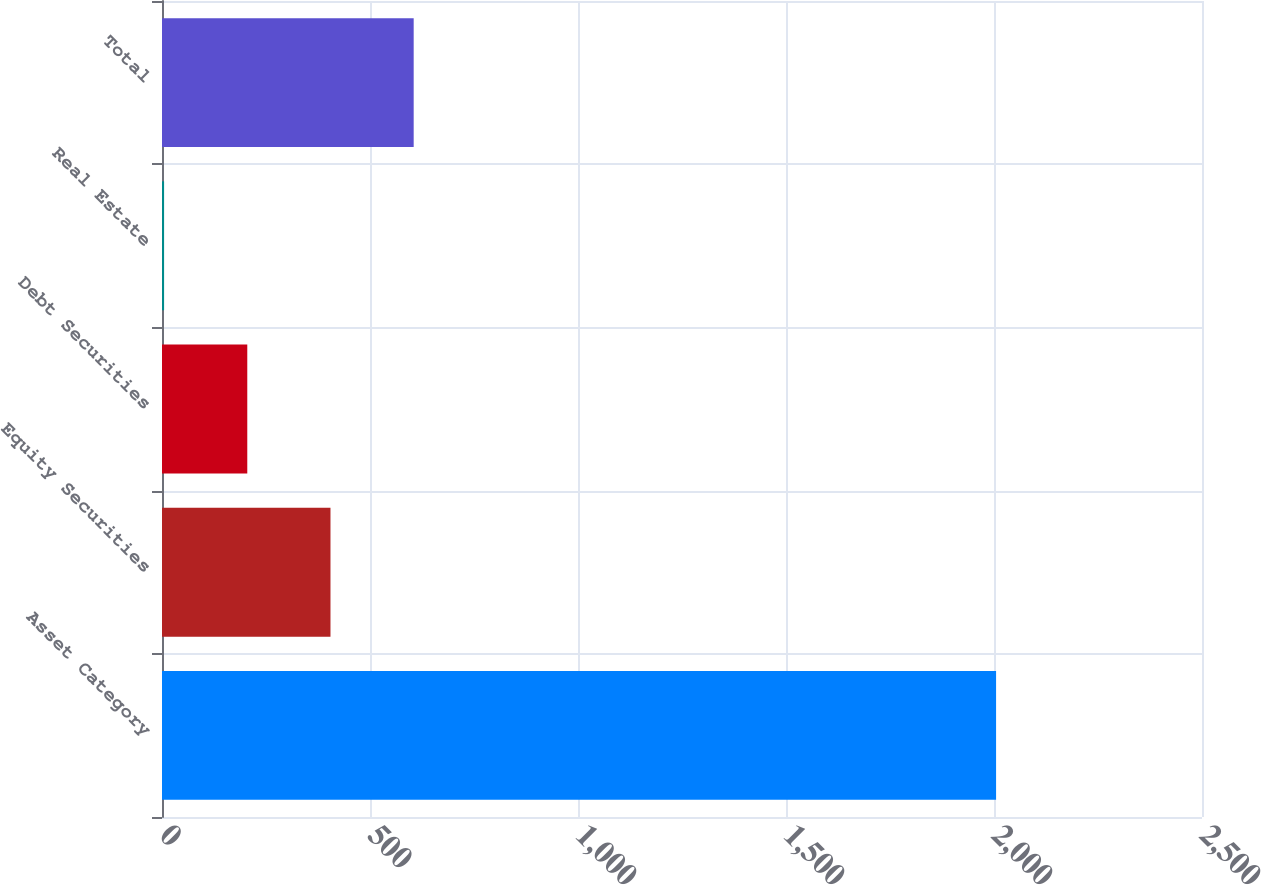Convert chart. <chart><loc_0><loc_0><loc_500><loc_500><bar_chart><fcel>Asset Category<fcel>Equity Securities<fcel>Debt Securities<fcel>Real Estate<fcel>Total<nl><fcel>2005<fcel>405<fcel>205<fcel>5<fcel>605<nl></chart> 